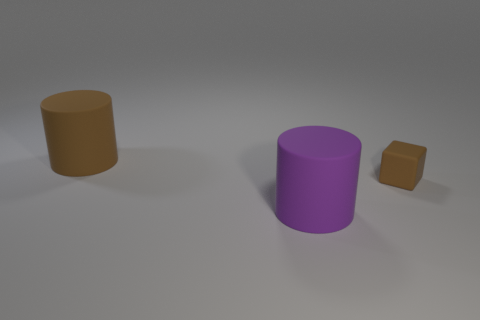How does the lighting in the scene affect the appearance of the objects? The lighting creates soft shadows on the ground, indicating a diffused light source, probably meant to simulate an overcast sky or indirect sunlight. This gives the objects a flattened appearance without strong highlights or deep shadows, which contributes to the matte look of their surface textures. 